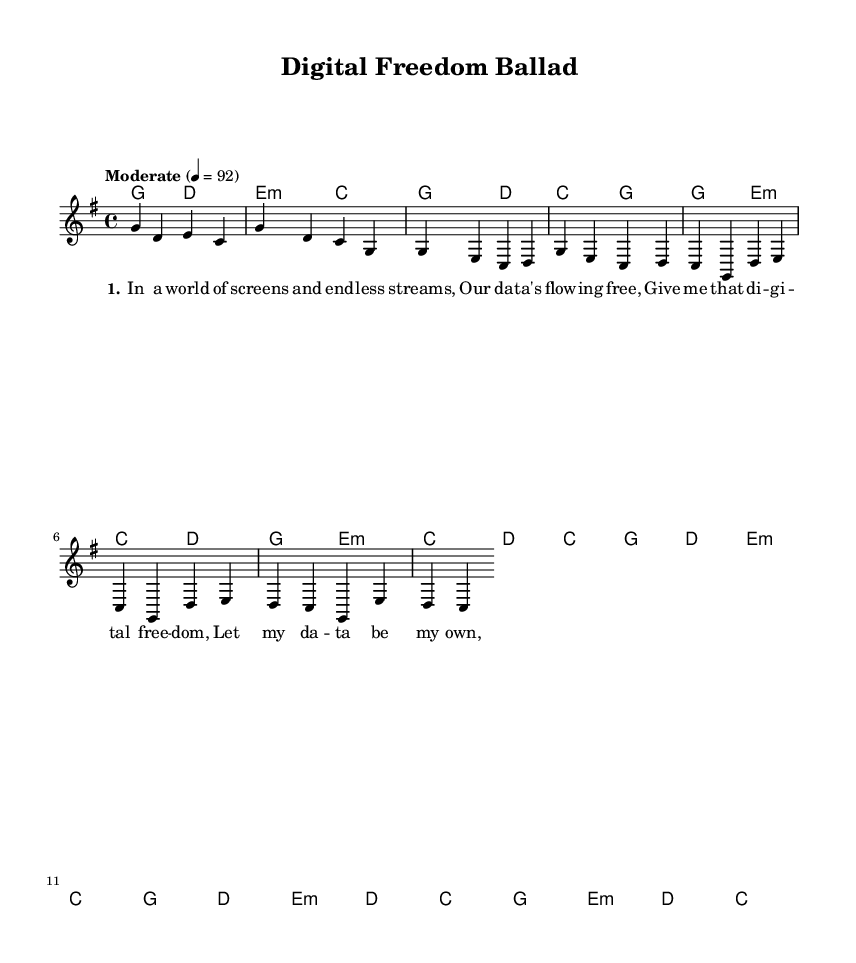What is the key signature of this music? The key signature is G major, which has one sharp (F#). This is found at the beginning of the music sheet, right after the clef.
Answer: G major What is the time signature of the piece? The time signature is 4/4, indicating four beats per measure, with a quarter note receiving one beat. This can be seen at the start of the music notation.
Answer: 4/4 What is the tempo marking for this piece? The tempo marking is "Moderate," which is specified just above the measures. The marking indicates a speed of 92 beats per minute.
Answer: Moderate How many measures are shown in the score provided? There are 8 measures visible in the score. Each measure is separated by a vertical line, and by counting them, we reach this total.
Answer: 8 What is the first chord used in the piece? The first chord is a G major chord, which is indicated at the beginning of the score within the chord names section.
Answer: G Which part of the song contains the lyrics "We'll build a new frontier"? The lyrics "We'll build a new frontier" are part of the bridge section of the song. This section is specifically labeled in the lyrics mode.
Answer: Bridge How does the chorus section begin? The chorus section begins with the lyrics "Give me that digital freedom," which are written under the melody in the score.
Answer: Give me that digital freedom 